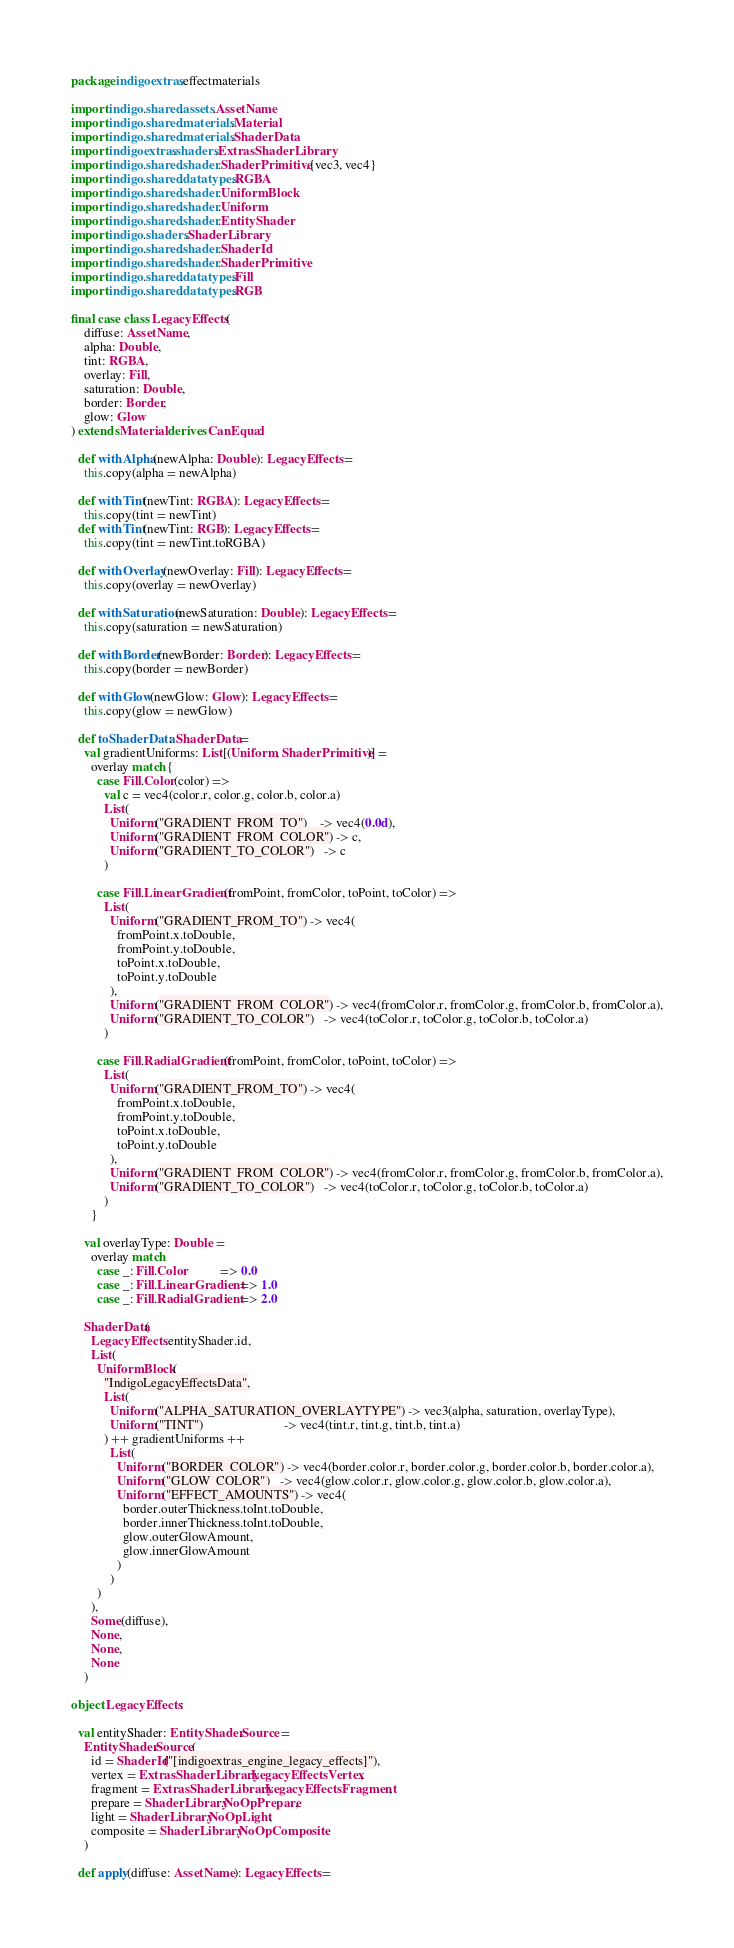<code> <loc_0><loc_0><loc_500><loc_500><_Scala_>package indigoextras.effectmaterials

import indigo.shared.assets.AssetName
import indigo.shared.materials.Material
import indigo.shared.materials.ShaderData
import indigoextras.shaders.ExtrasShaderLibrary
import indigo.shared.shader.ShaderPrimitive.{vec3, vec4}
import indigo.shared.datatypes.RGBA
import indigo.shared.shader.UniformBlock
import indigo.shared.shader.Uniform
import indigo.shared.shader.EntityShader
import indigo.shaders.ShaderLibrary
import indigo.shared.shader.ShaderId
import indigo.shared.shader.ShaderPrimitive
import indigo.shared.datatypes.Fill
import indigo.shared.datatypes.RGB

final case class LegacyEffects(
    diffuse: AssetName,
    alpha: Double,
    tint: RGBA,
    overlay: Fill,
    saturation: Double,
    border: Border,
    glow: Glow
) extends Material derives CanEqual:

  def withAlpha(newAlpha: Double): LegacyEffects =
    this.copy(alpha = newAlpha)

  def withTint(newTint: RGBA): LegacyEffects =
    this.copy(tint = newTint)
  def withTint(newTint: RGB): LegacyEffects =
    this.copy(tint = newTint.toRGBA)

  def withOverlay(newOverlay: Fill): LegacyEffects =
    this.copy(overlay = newOverlay)

  def withSaturation(newSaturation: Double): LegacyEffects =
    this.copy(saturation = newSaturation)

  def withBorder(newBorder: Border): LegacyEffects =
    this.copy(border = newBorder)

  def withGlow(newGlow: Glow): LegacyEffects =
    this.copy(glow = newGlow)

  def toShaderData: ShaderData =
    val gradientUniforms: List[(Uniform, ShaderPrimitive)] =
      overlay match {
        case Fill.Color(color) =>
          val c = vec4(color.r, color.g, color.b, color.a)
          List(
            Uniform("GRADIENT_FROM_TO")    -> vec4(0.0d),
            Uniform("GRADIENT_FROM_COLOR") -> c,
            Uniform("GRADIENT_TO_COLOR")   -> c
          )

        case Fill.LinearGradient(fromPoint, fromColor, toPoint, toColor) =>
          List(
            Uniform("GRADIENT_FROM_TO") -> vec4(
              fromPoint.x.toDouble,
              fromPoint.y.toDouble,
              toPoint.x.toDouble,
              toPoint.y.toDouble
            ),
            Uniform("GRADIENT_FROM_COLOR") -> vec4(fromColor.r, fromColor.g, fromColor.b, fromColor.a),
            Uniform("GRADIENT_TO_COLOR")   -> vec4(toColor.r, toColor.g, toColor.b, toColor.a)
          )

        case Fill.RadialGradient(fromPoint, fromColor, toPoint, toColor) =>
          List(
            Uniform("GRADIENT_FROM_TO") -> vec4(
              fromPoint.x.toDouble,
              fromPoint.y.toDouble,
              toPoint.x.toDouble,
              toPoint.y.toDouble
            ),
            Uniform("GRADIENT_FROM_COLOR") -> vec4(fromColor.r, fromColor.g, fromColor.b, fromColor.a),
            Uniform("GRADIENT_TO_COLOR")   -> vec4(toColor.r, toColor.g, toColor.b, toColor.a)
          )
      }

    val overlayType: Double =
      overlay match
        case _: Fill.Color          => 0.0
        case _: Fill.LinearGradient => 1.0
        case _: Fill.RadialGradient => 2.0

    ShaderData(
      LegacyEffects.entityShader.id,
      List(
        UniformBlock(
          "IndigoLegacyEffectsData",
          List(
            Uniform("ALPHA_SATURATION_OVERLAYTYPE") -> vec3(alpha, saturation, overlayType),
            Uniform("TINT")                         -> vec4(tint.r, tint.g, tint.b, tint.a)
          ) ++ gradientUniforms ++
            List(
              Uniform("BORDER_COLOR") -> vec4(border.color.r, border.color.g, border.color.b, border.color.a),
              Uniform("GLOW_COLOR")   -> vec4(glow.color.r, glow.color.g, glow.color.b, glow.color.a),
              Uniform("EFFECT_AMOUNTS") -> vec4(
                border.outerThickness.toInt.toDouble,
                border.innerThickness.toInt.toDouble,
                glow.outerGlowAmount,
                glow.innerGlowAmount
              )
            )
        )
      ),
      Some(diffuse),
      None,
      None,
      None
    )

object LegacyEffects:

  val entityShader: EntityShader.Source =
    EntityShader.Source(
      id = ShaderId("[indigoextras_engine_legacy_effects]"),
      vertex = ExtrasShaderLibrary.LegacyEffectsVertex,
      fragment = ExtrasShaderLibrary.LegacyEffectsFragment,
      prepare = ShaderLibrary.NoOpPrepare,
      light = ShaderLibrary.NoOpLight,
      composite = ShaderLibrary.NoOpComposite
    )

  def apply(diffuse: AssetName): LegacyEffects =</code> 